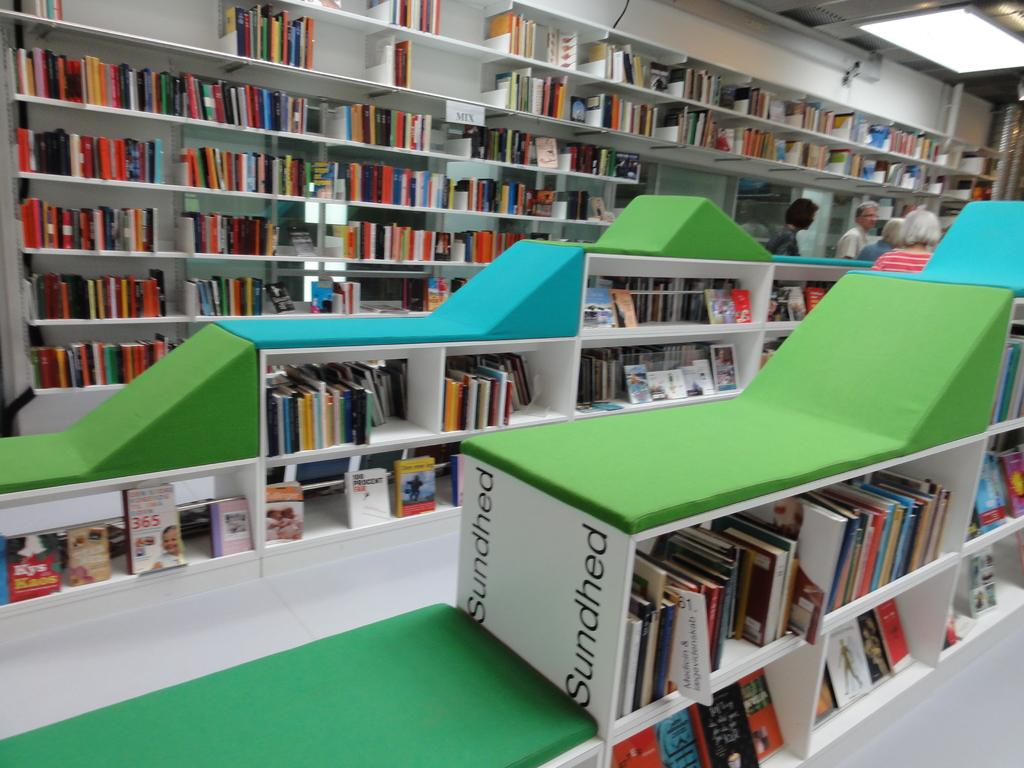<image>
Offer a succinct explanation of the picture presented. Books on library shelves and Sundhed written on the side of a shelf. 